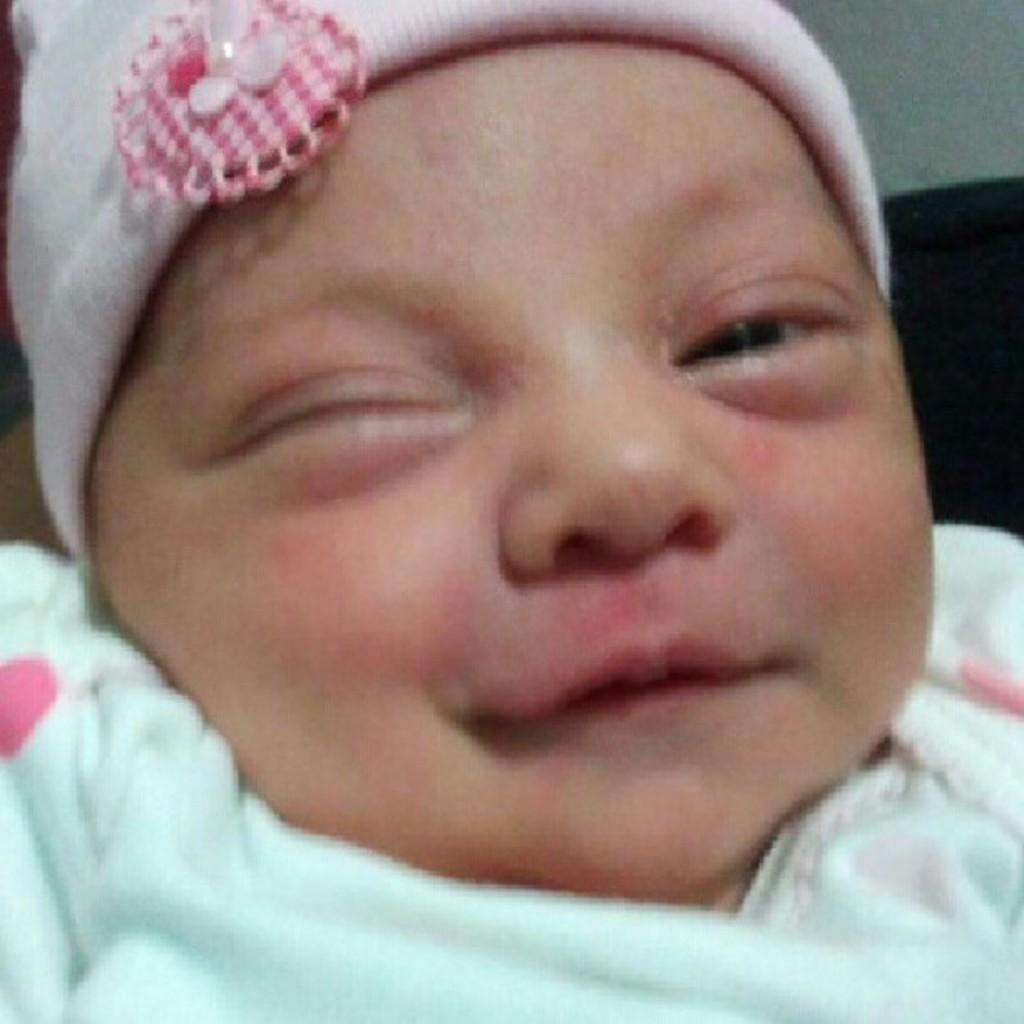What is the main subject of the image? The main subject of the image is a baby. What is the baby wearing on their head? The baby is wearing a monkey cap. What is the baby's facial expression in the image? The baby is smiling. Who is distributing the baby to the strangers in the image? There are no strangers or distribution of the baby in the image; it simply features a baby wearing a monkey cap and smiling. 